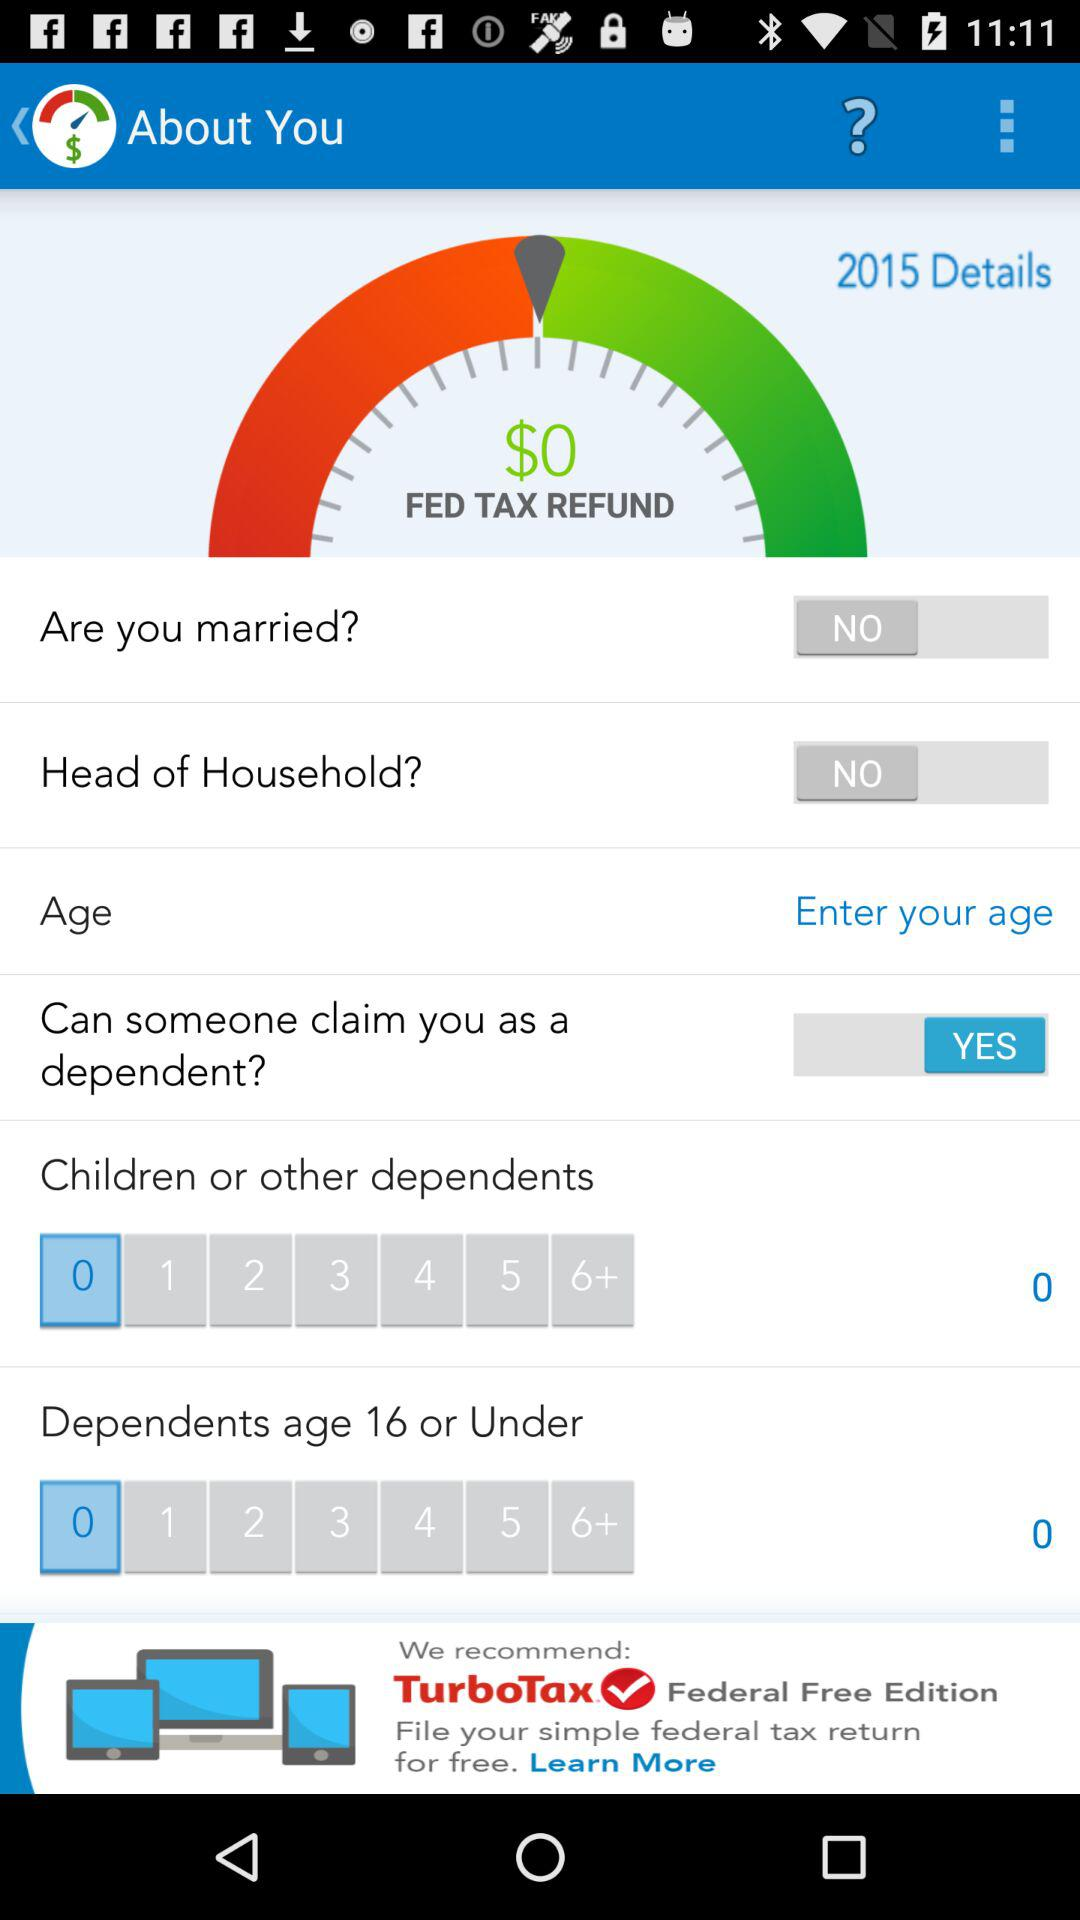What is the status of "Are you married"? The status is "off". 